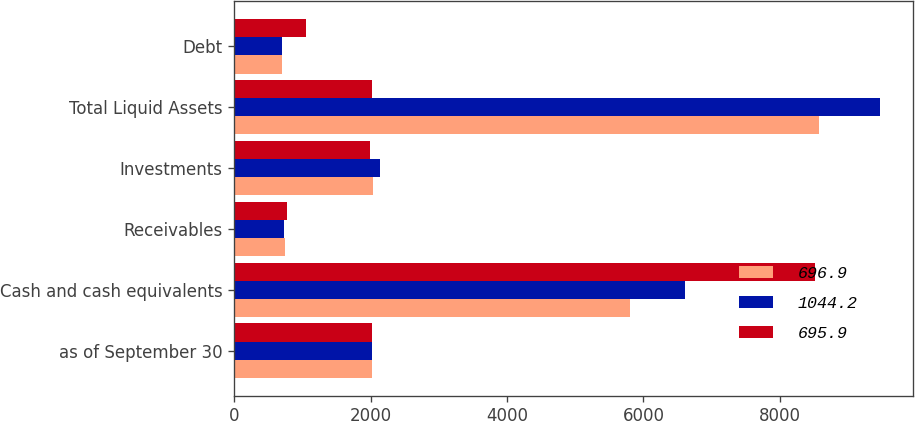Convert chart. <chart><loc_0><loc_0><loc_500><loc_500><stacked_bar_chart><ecel><fcel>as of September 30<fcel>Cash and cash equivalents<fcel>Receivables<fcel>Investments<fcel>Total Liquid Assets<fcel>Debt<nl><fcel>696.9<fcel>2019<fcel>5803.4<fcel>740<fcel>2029.4<fcel>8572.8<fcel>696.9<nl><fcel>1044.2<fcel>2018<fcel>6610.8<fcel>733.7<fcel>2130.6<fcel>9475.1<fcel>695.9<nl><fcel>695.9<fcel>2017<fcel>8523.3<fcel>767.8<fcel>1995.2<fcel>2018<fcel>1044.2<nl></chart> 